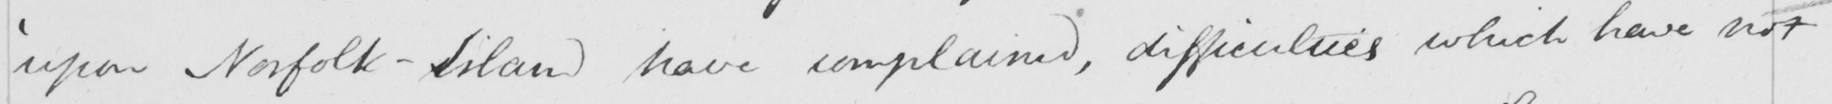Please provide the text content of this handwritten line. ' upon Norfolk-Island have complained , difficulties which have not 